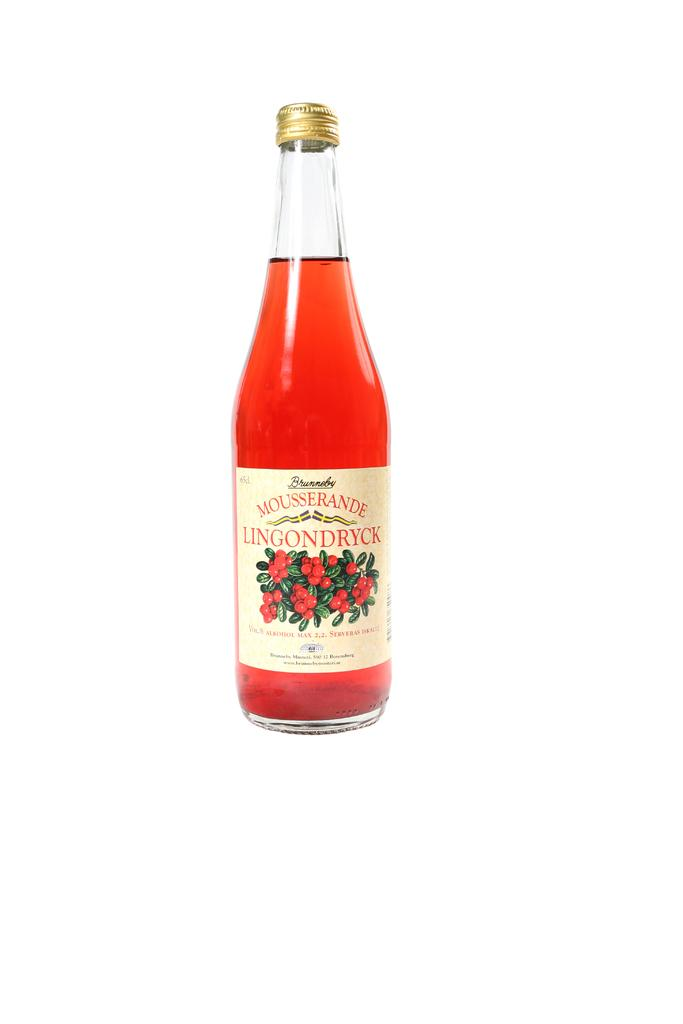What is in the bottle that is visible in the image? The bottle contains syrup. What feature does the bottle have to prevent the syrup from spilling? The bottle has a lid. How can the contents of the bottle be identified? The bottle has a label. What type of gold material is used to stitch the label on the bottle? There is no gold material or stitching present on the label of the bottle in the image. 